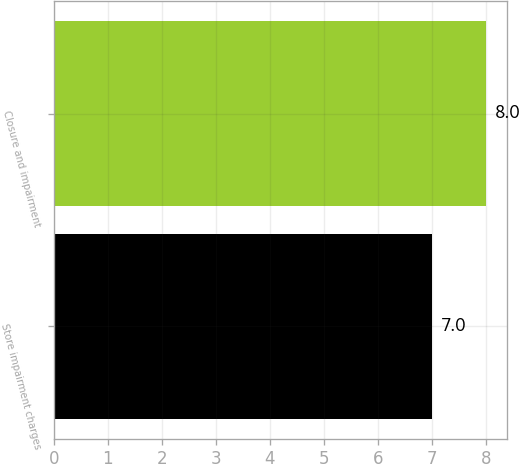Convert chart to OTSL. <chart><loc_0><loc_0><loc_500><loc_500><bar_chart><fcel>Store impairment charges<fcel>Closure and impairment<nl><fcel>7<fcel>8<nl></chart> 